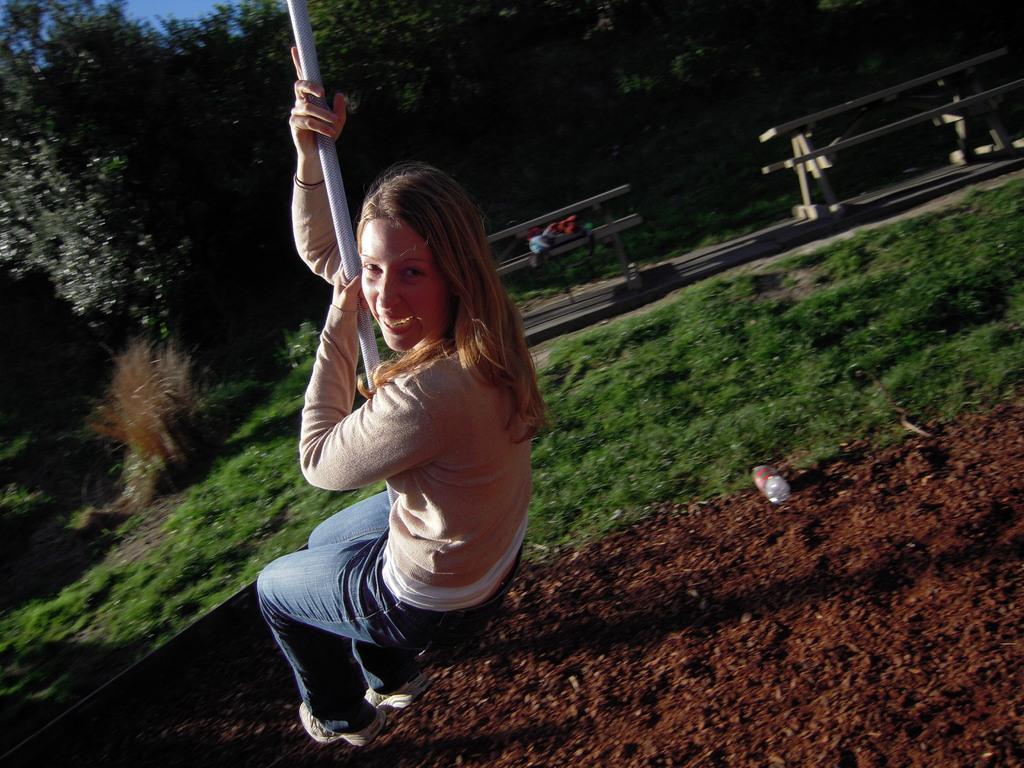Describe this image in one or two sentences. On the left side, there is a woman in a T-shirt, holding a pole, sitting on a surface and smiling. Below her, there is mud, on which there is a bottle. In the background, there are two benches and two tables arranged on a platform, beside this platform, there is grass on the ground, there are trees and there is blue sky. 